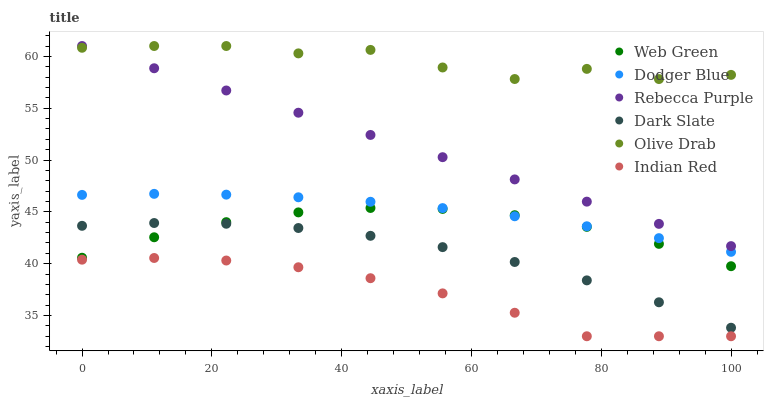Does Indian Red have the minimum area under the curve?
Answer yes or no. Yes. Does Olive Drab have the maximum area under the curve?
Answer yes or no. Yes. Does Dark Slate have the minimum area under the curve?
Answer yes or no. No. Does Dark Slate have the maximum area under the curve?
Answer yes or no. No. Is Rebecca Purple the smoothest?
Answer yes or no. Yes. Is Olive Drab the roughest?
Answer yes or no. Yes. Is Dark Slate the smoothest?
Answer yes or no. No. Is Dark Slate the roughest?
Answer yes or no. No. Does Indian Red have the lowest value?
Answer yes or no. Yes. Does Dark Slate have the lowest value?
Answer yes or no. No. Does Olive Drab have the highest value?
Answer yes or no. Yes. Does Dark Slate have the highest value?
Answer yes or no. No. Is Web Green less than Olive Drab?
Answer yes or no. Yes. Is Olive Drab greater than Web Green?
Answer yes or no. Yes. Does Rebecca Purple intersect Olive Drab?
Answer yes or no. Yes. Is Rebecca Purple less than Olive Drab?
Answer yes or no. No. Is Rebecca Purple greater than Olive Drab?
Answer yes or no. No. Does Web Green intersect Olive Drab?
Answer yes or no. No. 